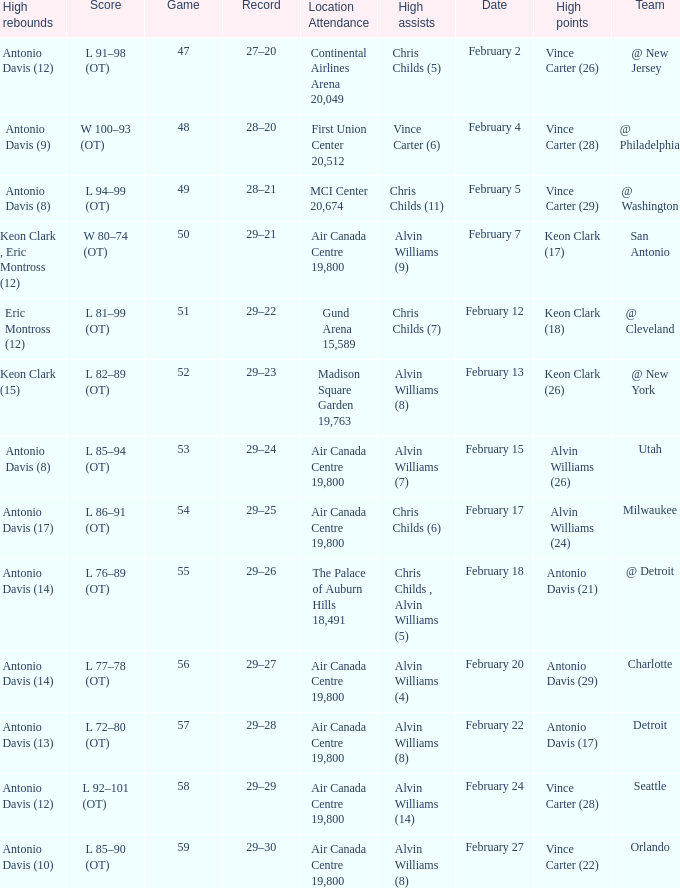What is the Team with a game of more than 56, and the score is l 85–90 (ot)? Orlando. 